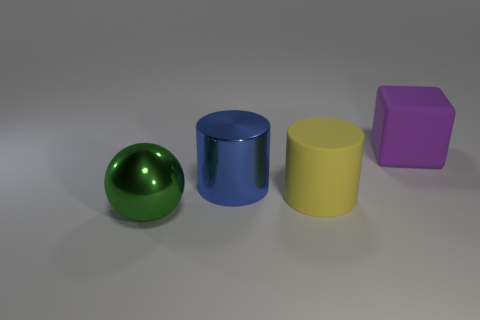Could you describe the positioning of the objects in terms of proximity? Certainly, the green ball is positioned farthest left; close to it is the blue cylinder. The yellow cylinder is almost at the same distance from the blue cylinder as the purple block is from the yellow cylinder. 